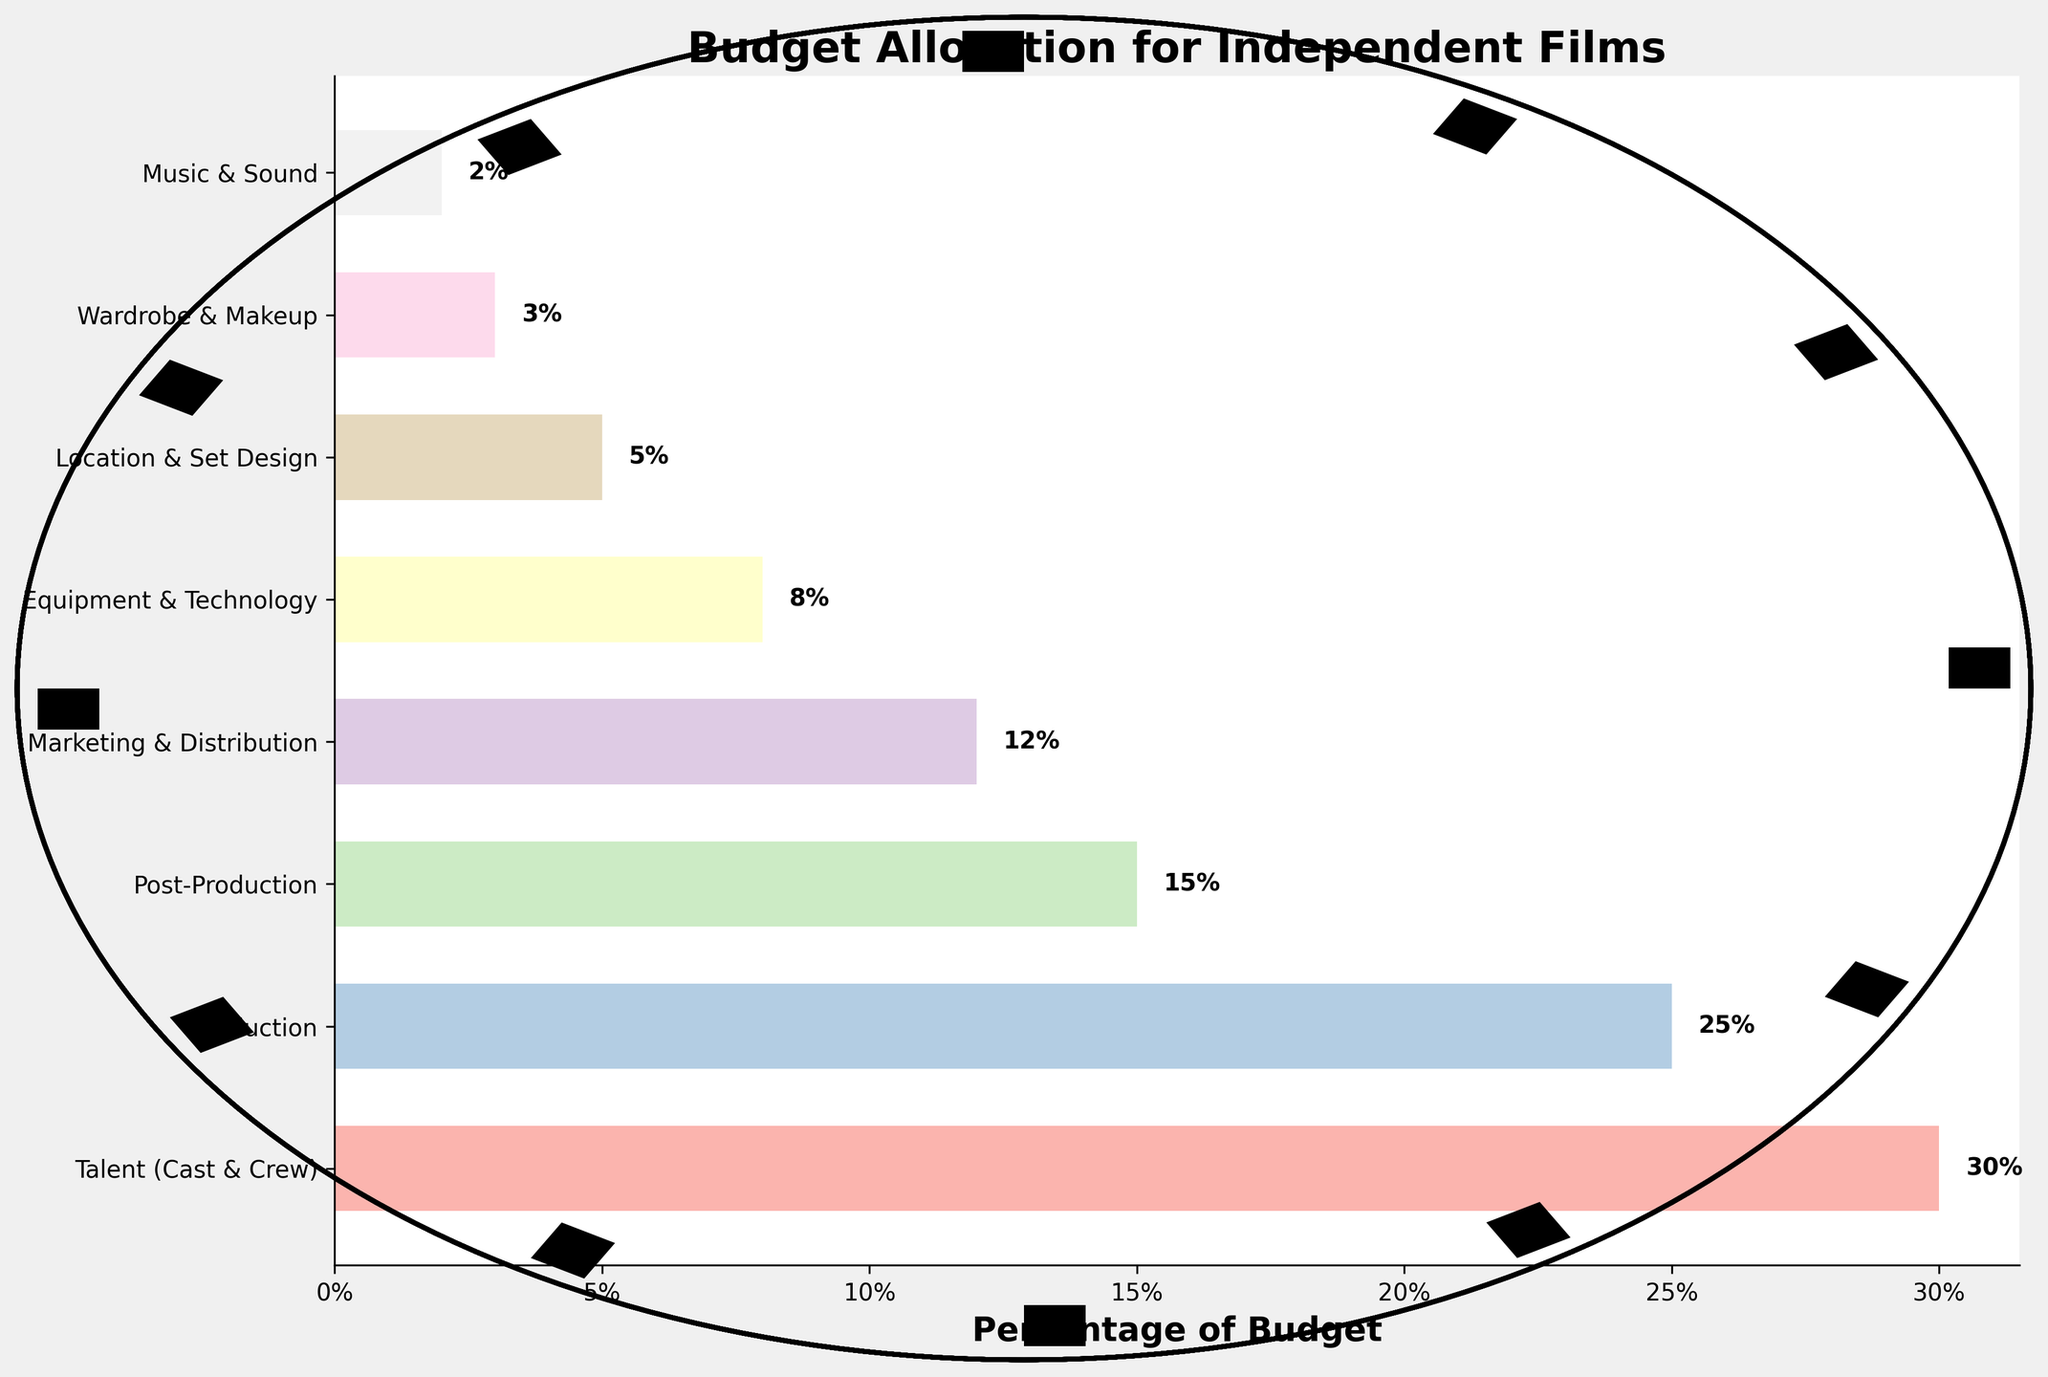What's the highest percentage allocated to a single department? The tallest bar represents the highest percentage, and in the figure, the department with the highest allocation is Talent (Cast & Crew) with 30%.
Answer: 30% Which department has the smallest budget allocation? The shortest bar on the chart indicates the department with the smallest budget allocation, which is Music & Sound. The percentage for this department is 2%.
Answer: Music & Sound What's the total budget allocation percentage for Production, Post-Production, and Marketing & Distribution combined? To find the total, sum the percentages of these departments: Production (25%), Post-Production (15%), and Marketing & Distribution (12%). 25% + 15% + 12% equals 52%.
Answer: 52% How much more budget is allocated to Talent (Cast & Crew) compared to Equipment & Technology? Subtract the percentage of Equipment & Technology (8%) from the percentage of Talent (Cast & Crew) (30%). The difference is 30% - 8% = 22%.
Answer: 22% Which department receives a higher budget allocation: Location & Set Design or Wardrobe & Makeup? Compare the heights of their bars. Location & Set Design has a percentage of 5%, while Wardrobe & Makeup has a percentage of 3%. Therefore, Location & Set Design receives a higher budget allocation.
Answer: Location & Set Design What is the average budget allocation percentage for all the departments? Sum all the percentages and divide by the number of departments. The total percentage is 30% + 25% + 15% + 12% + 8% + 5% + 3% + 2% = 100%. There are 8 departments, so the average is 100% / 8 = 12.5%.
Answer: 12.5% Which department has a percentage that is closest to the overall average budget allocation? The overall average budget allocation is 12.5%. Compare this average to each department's percentage. Marketing & Distribution has a percentage of 12%, which is closest to 12.5%.
Answer: Marketing & Distribution By how much does the budget allocation for Post-Production exceed that of Music & Sound? Subtract the percentage of Music & Sound (2%) from the percentage of Post-Production (15%). The difference is 15% - 2% = 13%.
Answer: 13% Is the combined budget of Wardrobe & Makeup and Location & Set Design equal to the budget for Post-Production? Sum the percentages of Wardrobe & Makeup (3%) and Location & Set Design (5%), which is 3% + 5% = 8%. Compare this with the percentage for Post-Production (15%). They are not equal.
Answer: No 